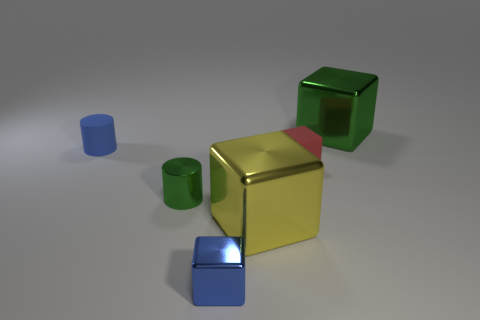Add 2 blue metallic things. How many objects exist? 8 Subtract all blue cubes. How many cubes are left? 3 Subtract all green cubes. How many cubes are left? 3 Subtract 3 cubes. How many cubes are left? 1 Subtract 0 brown cylinders. How many objects are left? 6 Subtract all cylinders. How many objects are left? 4 Subtract all brown blocks. Subtract all gray spheres. How many blocks are left? 4 Subtract all yellow blocks. How many green cylinders are left? 1 Subtract all large green shiny things. Subtract all small blocks. How many objects are left? 3 Add 3 small red things. How many small red things are left? 4 